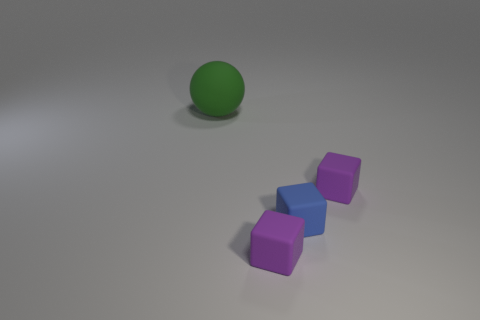There is a purple thing behind the small blue thing; what number of green rubber objects are to the right of it?
Offer a terse response. 0. What is the material of the green object?
Offer a very short reply. Rubber. There is a big thing; how many rubber objects are on the right side of it?
Ensure brevity in your answer.  3. What number of balls are the same color as the large object?
Keep it short and to the point. 0. Is the number of large yellow rubber cylinders greater than the number of tiny matte objects?
Provide a short and direct response. No. What size is the rubber object that is both behind the small blue block and left of the blue matte thing?
Provide a succinct answer. Large. Is the number of tiny purple cubes less than the number of tiny blue metallic objects?
Offer a very short reply. No. Are there any small matte cubes that are in front of the tiny matte object behind the blue rubber block?
Offer a terse response. Yes. Are there any rubber cubes that are left of the matte sphere behind the tiny matte object behind the blue thing?
Ensure brevity in your answer.  No. There is a tiny purple thing that is behind the blue block; is its shape the same as the purple rubber thing on the left side of the blue rubber cube?
Provide a succinct answer. Yes. 